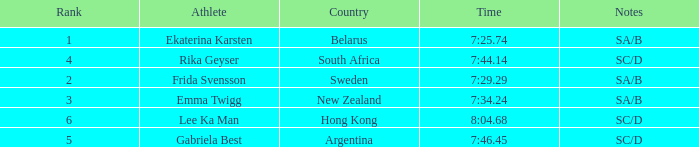What is the time of frida svensson's race that had sa/b under the notes? 7:29.29. 